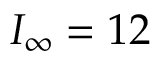<formula> <loc_0><loc_0><loc_500><loc_500>I _ { \infty } = 1 2 \</formula> 